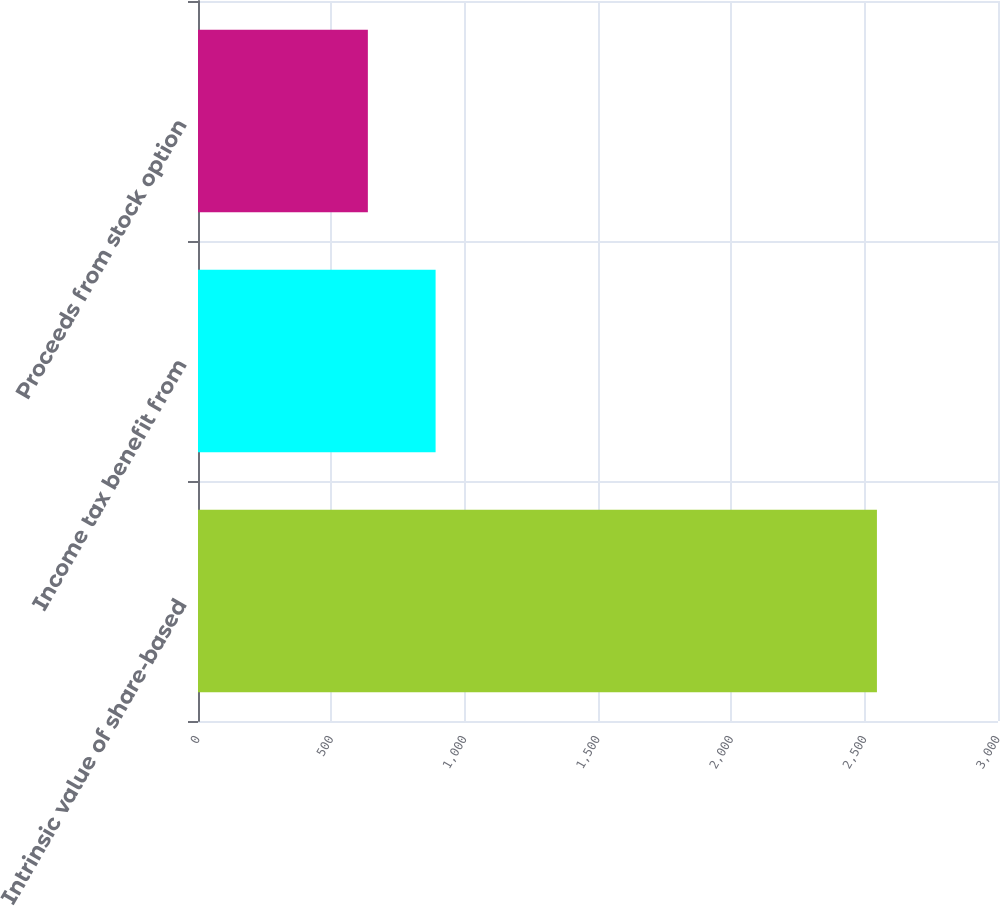Convert chart to OTSL. <chart><loc_0><loc_0><loc_500><loc_500><bar_chart><fcel>Intrinsic value of share-based<fcel>Income tax benefit from<fcel>Proceeds from stock option<nl><fcel>2546<fcel>891<fcel>637<nl></chart> 